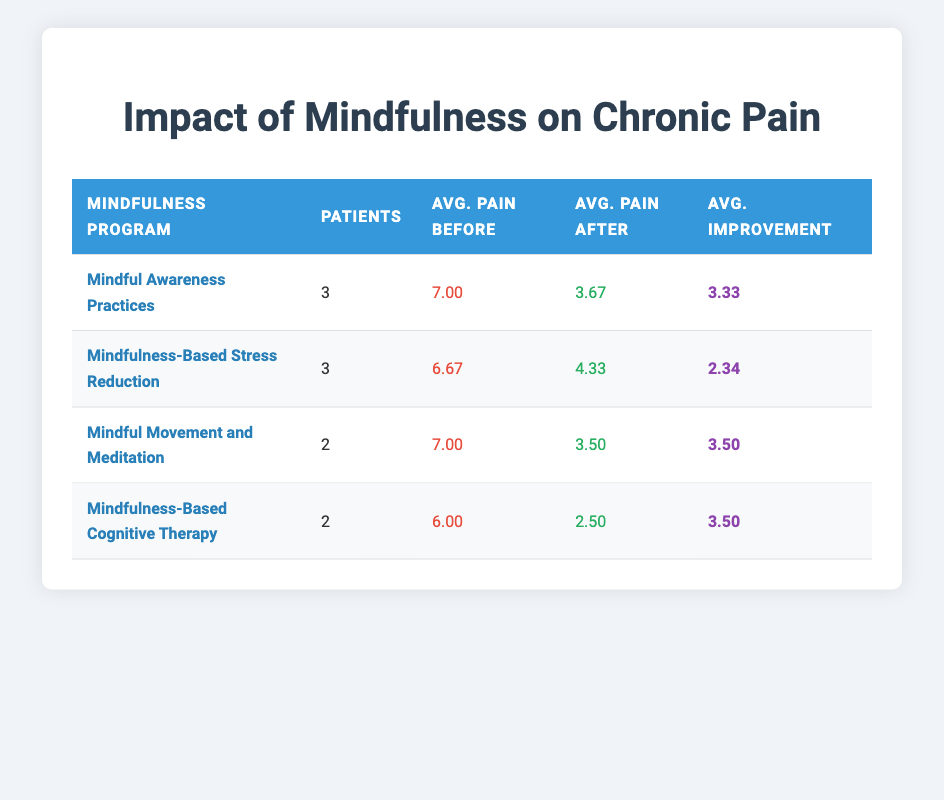What is the average pain severity before mindfulness interventions across all programs? To find the average pain severity before interventions, sum the "Avg. Pain Before" values from each program: 7.00 + 6.67 + 7.00 + 6.00 = 26.67. Then, divide by the number of programs (4): 26.67 / 4 = 6.67.
Answer: 6.67 What is the average pain severity after mindfulness interventions for the "Mindfulness-Based Stress Reduction" program? The average pain severity after the "Mindfulness-Based Stress Reduction" program is listed as 4.33 in the table, which is taken directly from the "Avg. Pain After" column for that program.
Answer: 4.33 Was there more average improvement in pain severity for "Mindful Movement and Meditation" than for "Mindfulness-Based Cognitive Therapy"? The average improvement for "Mindful Movement and Meditation" is 3.50 and for "Mindfulness-Based Cognitive Therapy" is also 3.50. Since both values are equal, there was no greater improvement in either program.
Answer: No How many patients participated in the "Mindful Awareness Practices" program? The table indicates that there are 3 patients who participated in the "Mindful Awareness Practices" program, as this value is specified under the "Patients" column for this program.
Answer: 3 What is the total average improvement in pain severity across all mindfulness programs? To calculate the total average improvement, we sum the average improvement values for each program (3.33 + 2.34 + 3.50 + 3.50) = 12.67. Then we divide this sum by the number of programs (4): 12.67 / 4 = 3.17.
Answer: 3.17 Did any mindfulness program demonstrate an average pain severity reduction greater than 3? The reduction (average improvement) values for "Mindful Awareness Practices," "Mindful Movement and Meditation," and "Mindfulness-Based Cognitive Therapy" are all greater than 3 (3.33 and 3.50). Therefore, yes, these programs demonstrated a significant reduction.
Answer: Yes Which mindfulness program had the highest average pain severity before the intervention? By reviewing the "Avg. Pain Before" column, we see that "Mindful Awareness Practices" had the highest average pain severity before the intervention, at 7.00.
Answer: Mindful Awareness Practices What is the lowest average pain severity after any mindfulness program? The table shows that the lowest average pain severity after any program is 2.50 from "Mindfulness-Based Cognitive Therapy." This is found directly in the "Avg. Pain After" column for that program.
Answer: 2.50 